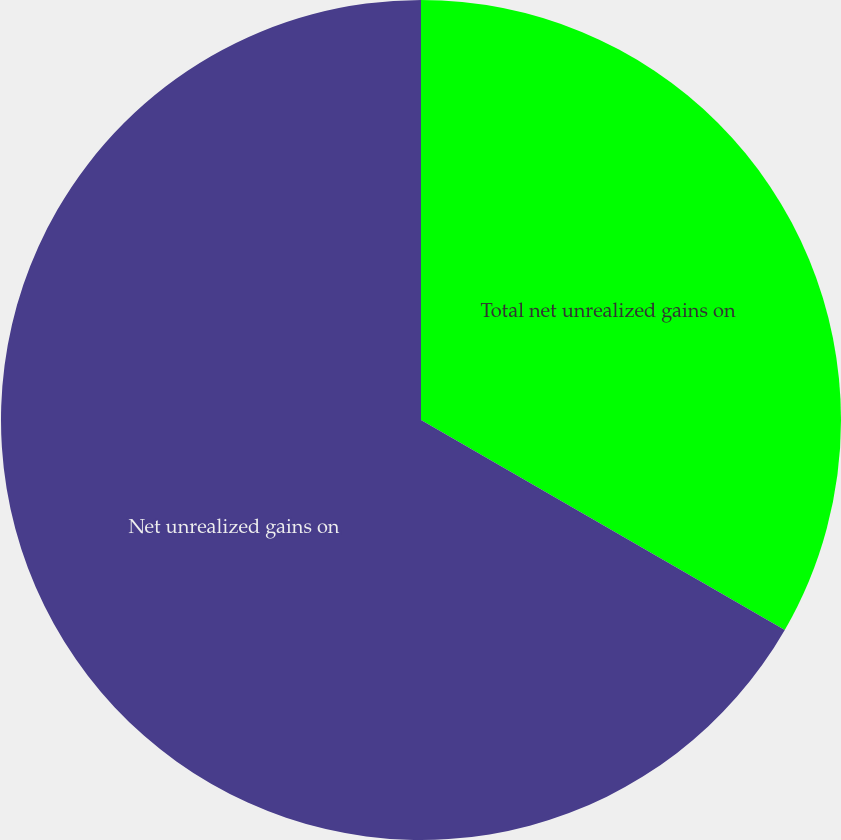<chart> <loc_0><loc_0><loc_500><loc_500><pie_chart><fcel>Total net unrealized gains on<fcel>Net unrealized gains on<nl><fcel>33.33%<fcel>66.67%<nl></chart> 